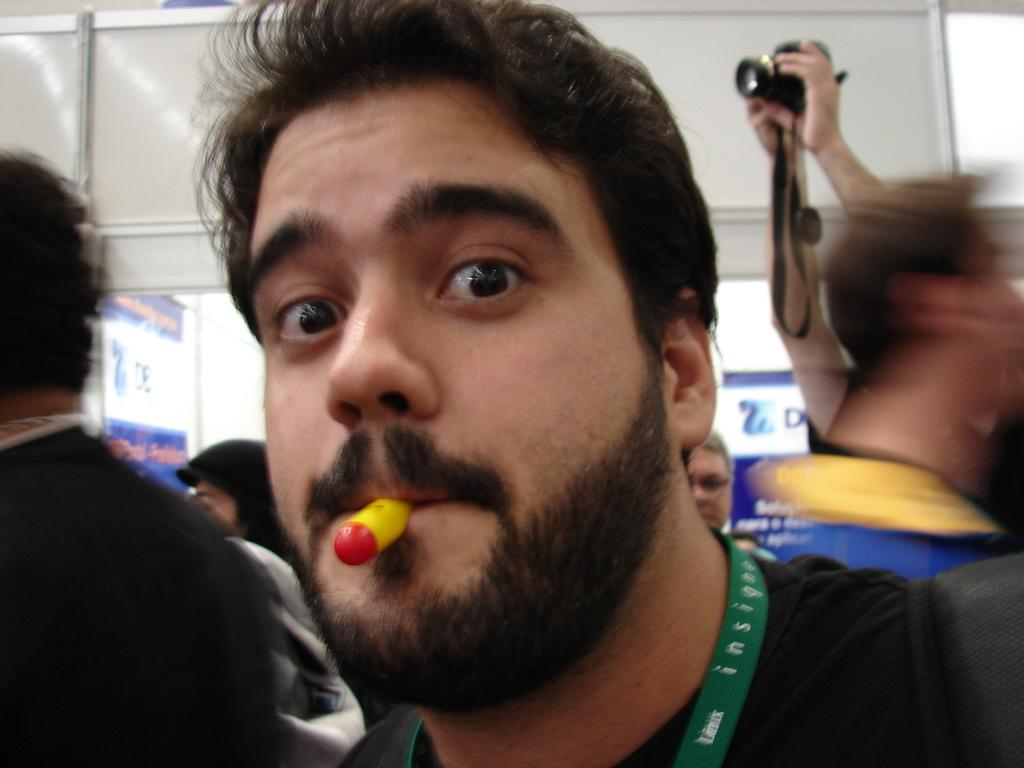Who or what is present in the image? There are people in the image. What is the person on the right side of the image doing? A person's hand is holding a camera on the right side of the image. What can be seen in the background of the image? There is a wall and a door in the background of the image. How many beams are visible in the image? There are no beams visible in the image. What type of loss is being experienced by the person in the image? There is no indication of any loss being experienced by the person in the image. 